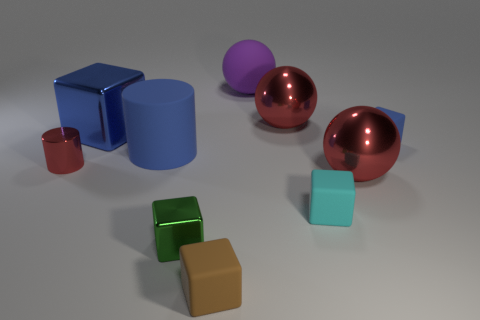Subtract all metallic balls. How many balls are left? 1 Subtract 1 cubes. How many cubes are left? 4 Subtract all brown cubes. How many cubes are left? 4 Subtract all purple spheres. How many blue blocks are left? 2 Subtract 1 green cubes. How many objects are left? 9 Subtract all balls. How many objects are left? 7 Subtract all green spheres. Subtract all blue cubes. How many spheres are left? 3 Subtract all rubber things. Subtract all red metallic balls. How many objects are left? 3 Add 5 red balls. How many red balls are left? 7 Add 8 small brown shiny cubes. How many small brown shiny cubes exist? 8 